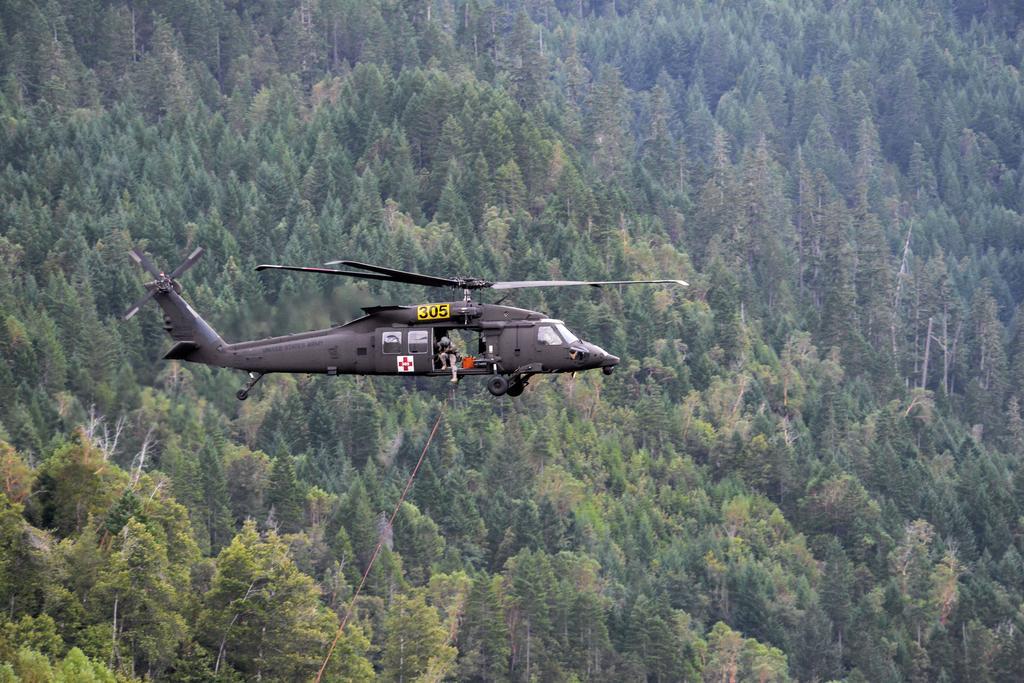Describe this image in one or two sentences. In the image there is a helicopter flying in the air, behind it there are trees all over the image. 